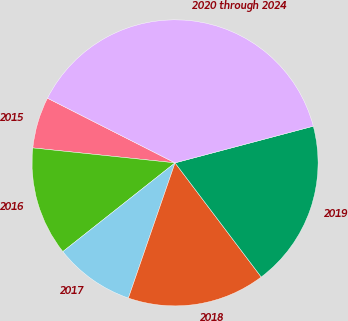<chart> <loc_0><loc_0><loc_500><loc_500><pie_chart><fcel>2015<fcel>2016<fcel>2017<fcel>2018<fcel>2019<fcel>2020 through 2024<nl><fcel>5.8%<fcel>12.32%<fcel>9.06%<fcel>15.58%<fcel>18.84%<fcel>38.41%<nl></chart> 